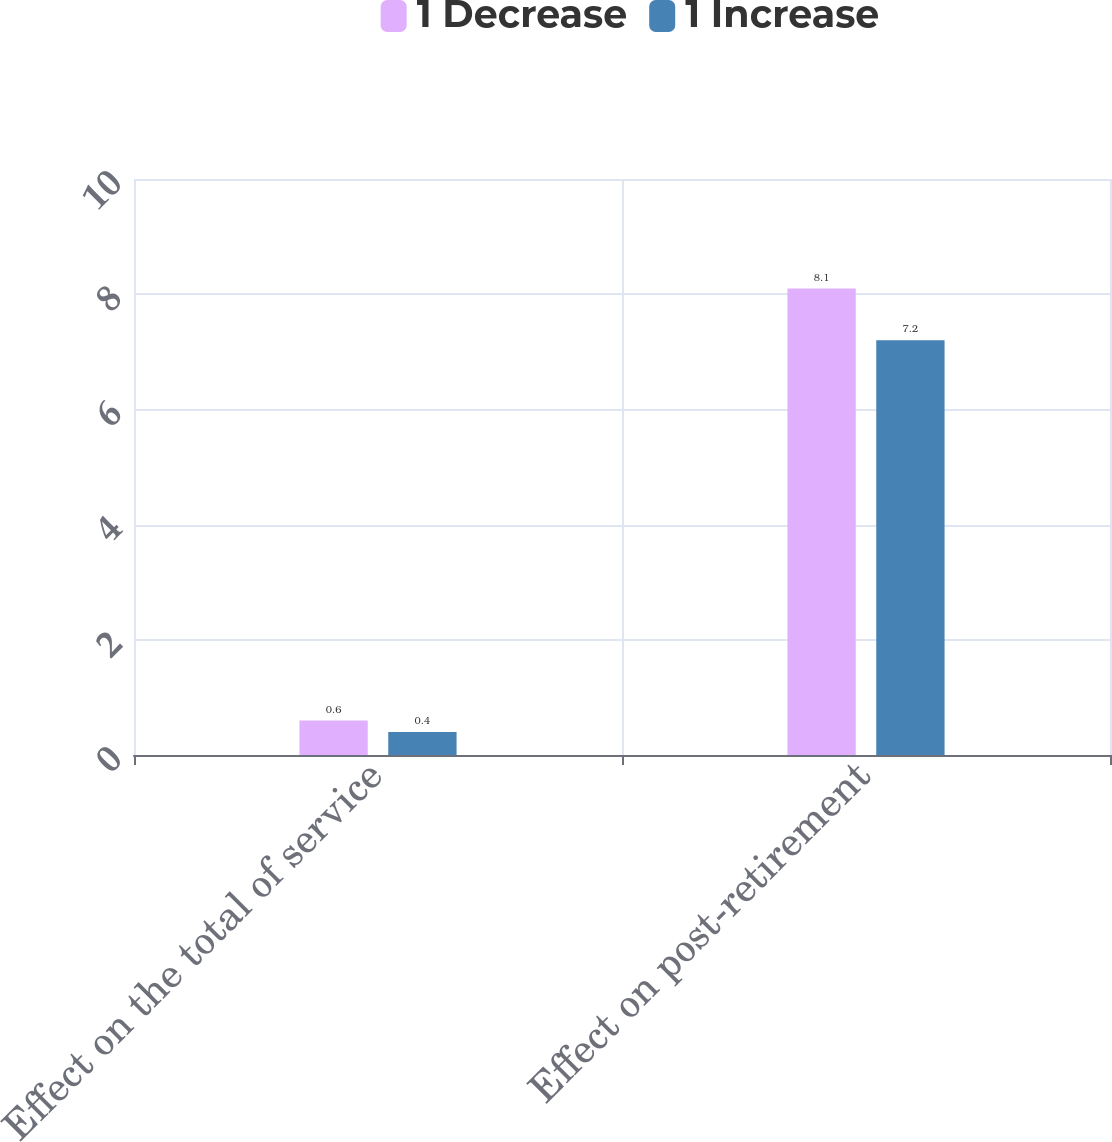<chart> <loc_0><loc_0><loc_500><loc_500><stacked_bar_chart><ecel><fcel>Effect on the total of service<fcel>Effect on post-retirement<nl><fcel>1 Decrease<fcel>0.6<fcel>8.1<nl><fcel>1 Increase<fcel>0.4<fcel>7.2<nl></chart> 